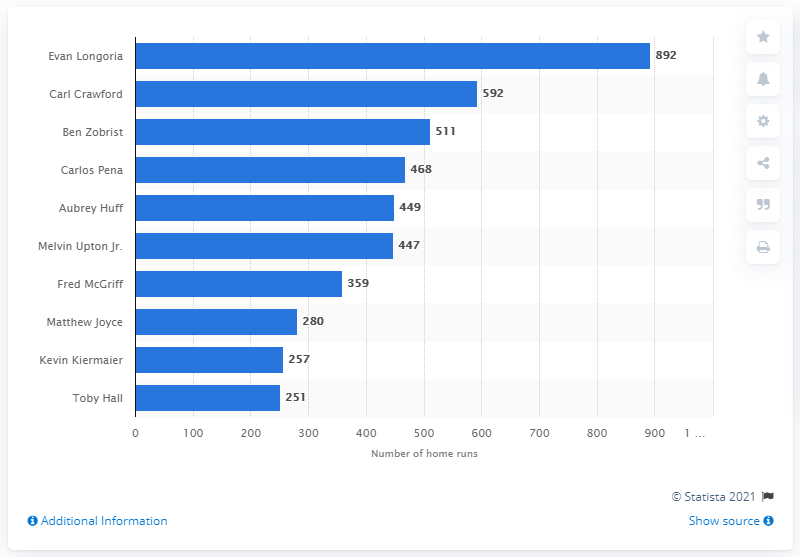Give some essential details in this illustration. The Tampa Bay Rays franchise history has been led by the impressive Evan Longoria, who has accumulated the most RBI's of all time. Evan Longoria has batted a total of 892 runs in his career. 